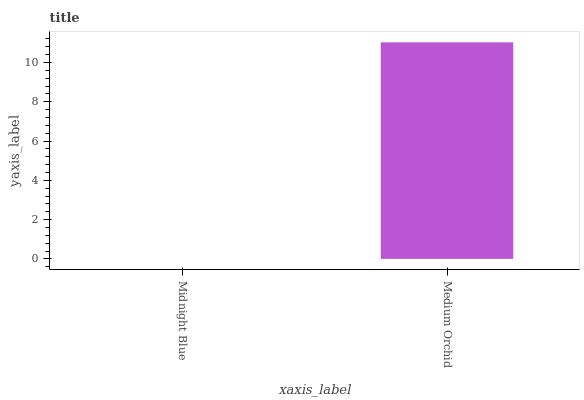Is Midnight Blue the minimum?
Answer yes or no. Yes. Is Medium Orchid the maximum?
Answer yes or no. Yes. Is Medium Orchid the minimum?
Answer yes or no. No. Is Medium Orchid greater than Midnight Blue?
Answer yes or no. Yes. Is Midnight Blue less than Medium Orchid?
Answer yes or no. Yes. Is Midnight Blue greater than Medium Orchid?
Answer yes or no. No. Is Medium Orchid less than Midnight Blue?
Answer yes or no. No. Is Medium Orchid the high median?
Answer yes or no. Yes. Is Midnight Blue the low median?
Answer yes or no. Yes. Is Midnight Blue the high median?
Answer yes or no. No. Is Medium Orchid the low median?
Answer yes or no. No. 